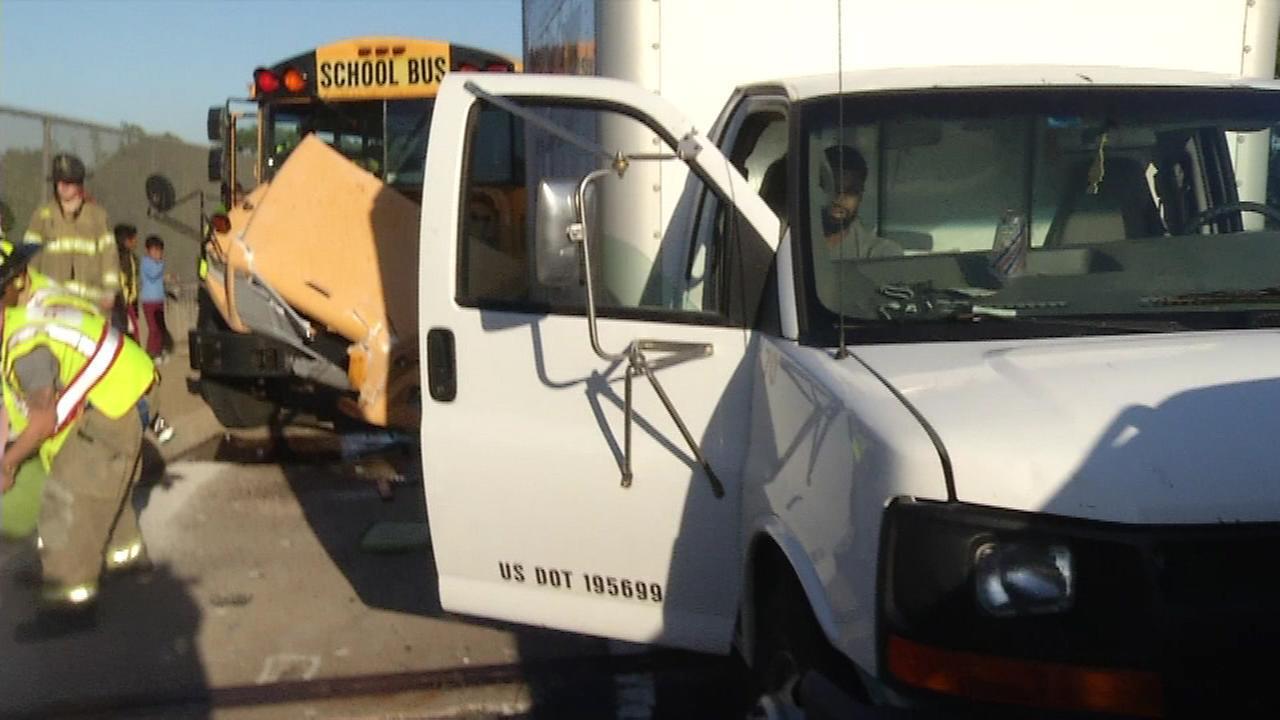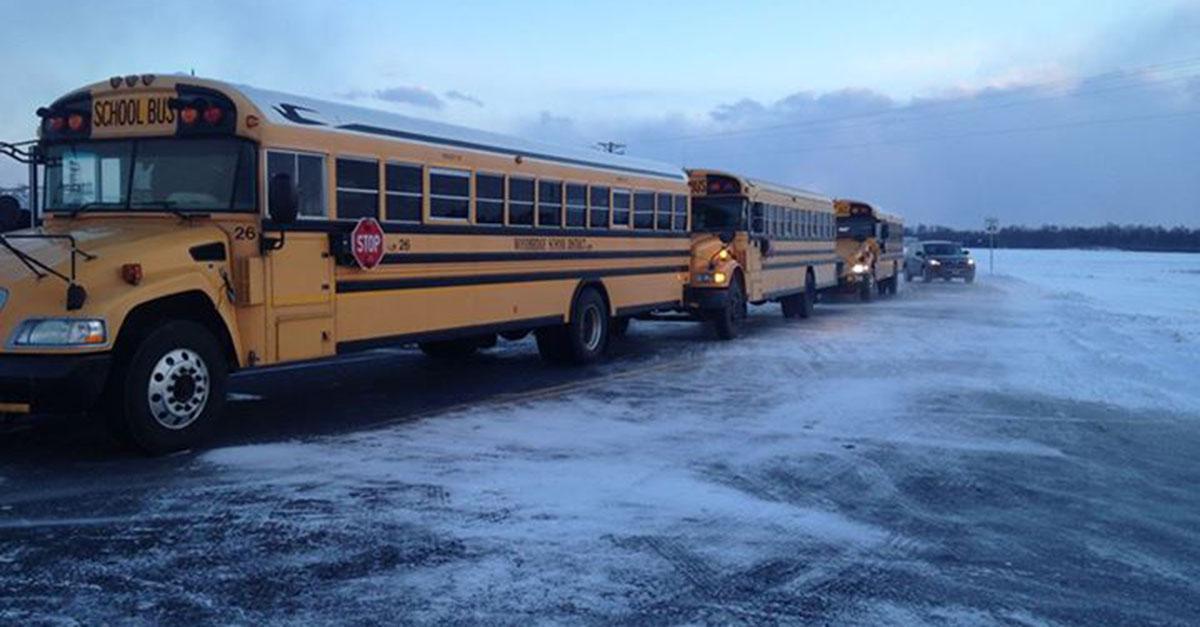The first image is the image on the left, the second image is the image on the right. Given the left and right images, does the statement "In one of the images you can see firemen tending to an accident between a school bus and a white truck." hold true? Answer yes or no. Yes. The first image is the image on the left, the second image is the image on the right. Considering the images on both sides, is "A white truck is visible in the left image." valid? Answer yes or no. Yes. 